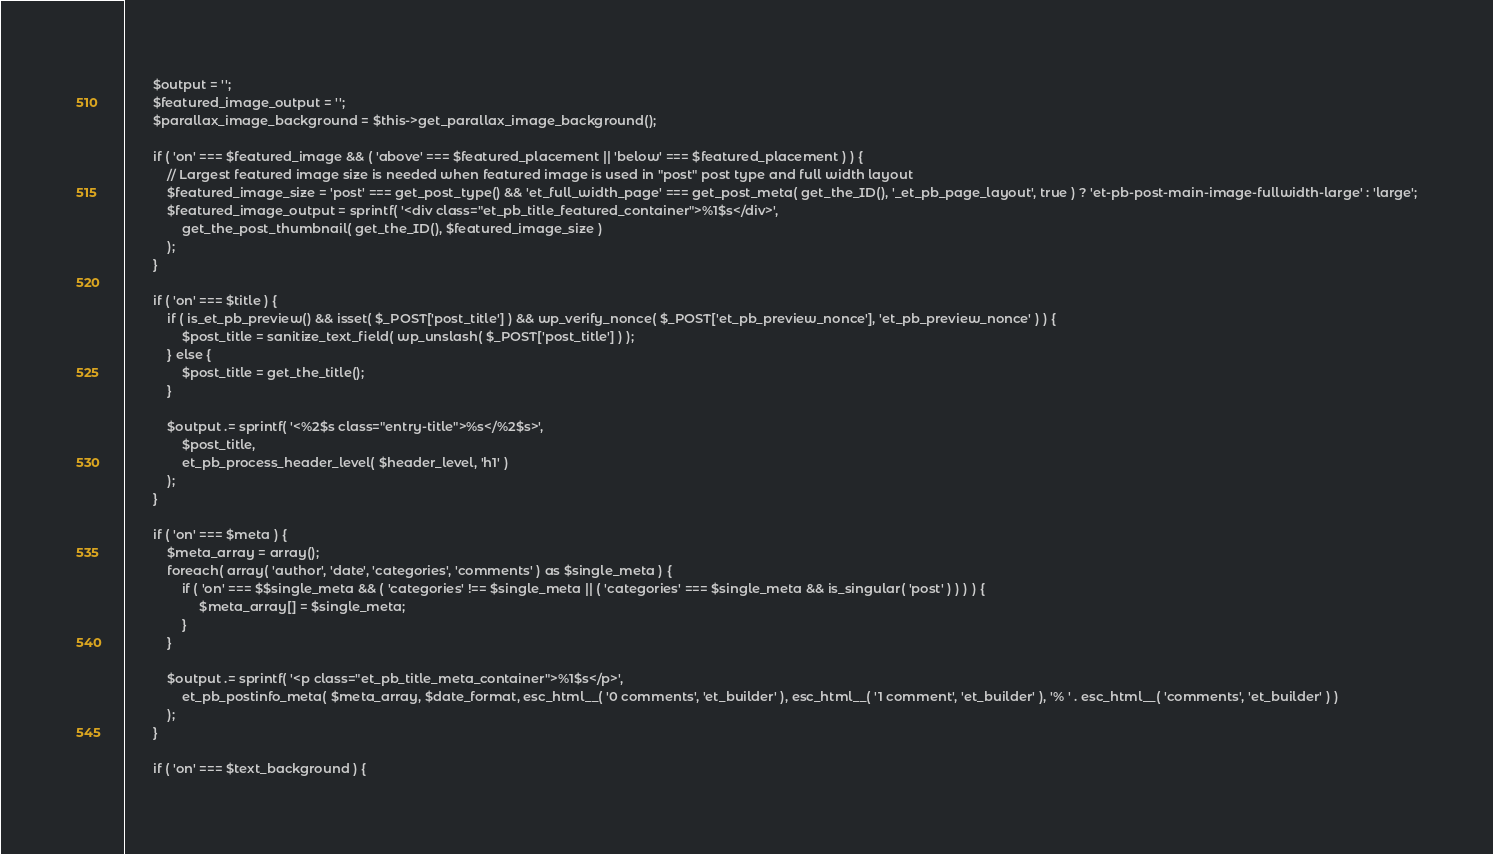Convert code to text. <code><loc_0><loc_0><loc_500><loc_500><_PHP_>
		$output = '';
		$featured_image_output = '';
		$parallax_image_background = $this->get_parallax_image_background();

		if ( 'on' === $featured_image && ( 'above' === $featured_placement || 'below' === $featured_placement ) ) {
			// Largest featured image size is needed when featured image is used in "post" post type and full width layout
			$featured_image_size = 'post' === get_post_type() && 'et_full_width_page' === get_post_meta( get_the_ID(), '_et_pb_page_layout', true ) ? 'et-pb-post-main-image-fullwidth-large' : 'large';
			$featured_image_output = sprintf( '<div class="et_pb_title_featured_container">%1$s</div>',
				get_the_post_thumbnail( get_the_ID(), $featured_image_size )
			);
		}

		if ( 'on' === $title ) {
			if ( is_et_pb_preview() && isset( $_POST['post_title'] ) && wp_verify_nonce( $_POST['et_pb_preview_nonce'], 'et_pb_preview_nonce' ) ) {
				$post_title = sanitize_text_field( wp_unslash( $_POST['post_title'] ) );
			} else {
				$post_title = get_the_title();
			}

			$output .= sprintf( '<%2$s class="entry-title">%s</%2$s>',
				$post_title,
				et_pb_process_header_level( $header_level, 'h1' )
			);
		}

		if ( 'on' === $meta ) {
			$meta_array = array();
			foreach( array( 'author', 'date', 'categories', 'comments' ) as $single_meta ) {
				if ( 'on' === $$single_meta && ( 'categories' !== $single_meta || ( 'categories' === $single_meta && is_singular( 'post' ) ) ) ) {
					 $meta_array[] = $single_meta;
				}
			}

			$output .= sprintf( '<p class="et_pb_title_meta_container">%1$s</p>',
				et_pb_postinfo_meta( $meta_array, $date_format, esc_html__( '0 comments', 'et_builder' ), esc_html__( '1 comment', 'et_builder' ), '% ' . esc_html__( 'comments', 'et_builder' ) )
			);
		}

		if ( 'on' === $text_background ) {</code> 